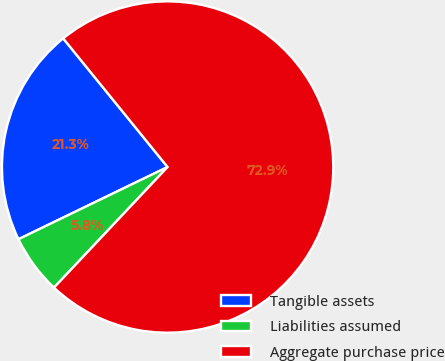<chart> <loc_0><loc_0><loc_500><loc_500><pie_chart><fcel>Tangible assets<fcel>Liabilities assumed<fcel>Aggregate purchase price<nl><fcel>21.33%<fcel>5.8%<fcel>72.88%<nl></chart> 